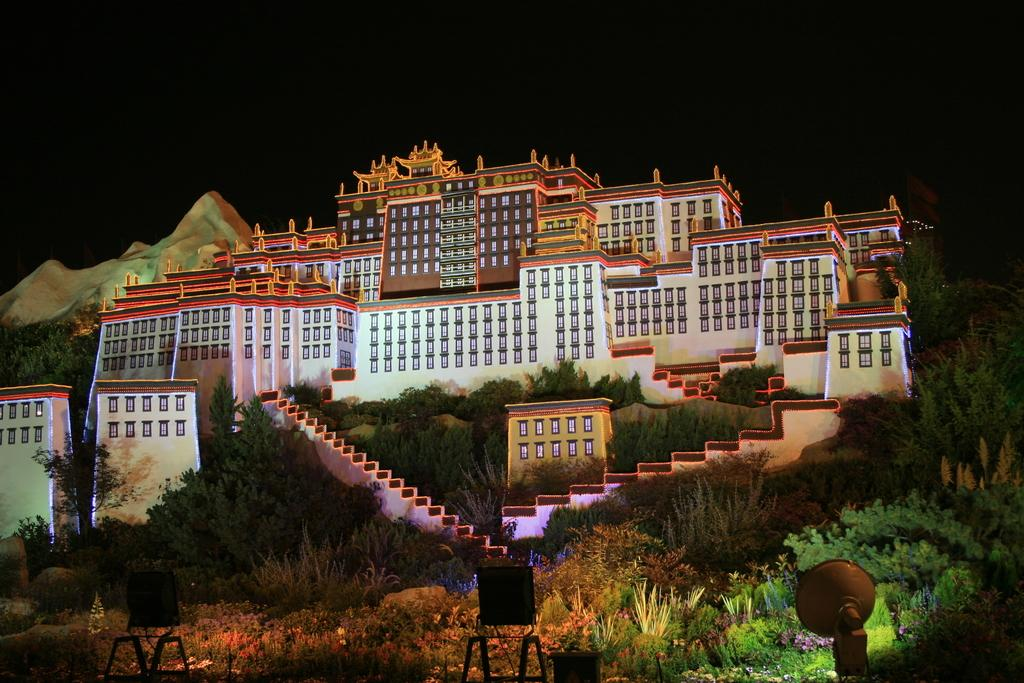What type of structures are present in the image? There are buildings in the image. What architectural feature can be seen in the image? There are stairs in the image. What type of vegetation is present in the image? There are trees in the image. What type of decorative elements can be seen in the image? There are flowers in the image. What type of illumination is present in the image? There are lights in the image. What is the color of the background in the image? The background of the image is black. Can you tell me how many fairies are dancing around the flowers in the image? There are no fairies present in the image; it features buildings, trees, stairs, lights, and flowers. What type of calendar is hanging on the wall in the image? There is no calendar present in the image. 